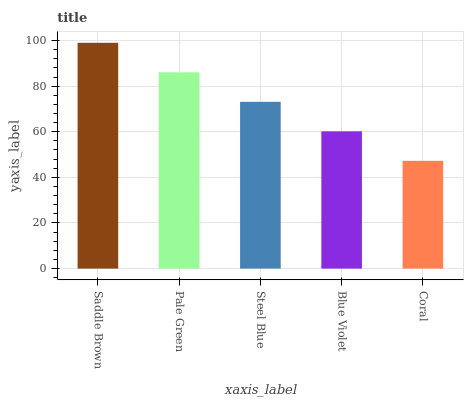Is Coral the minimum?
Answer yes or no. Yes. Is Saddle Brown the maximum?
Answer yes or no. Yes. Is Pale Green the minimum?
Answer yes or no. No. Is Pale Green the maximum?
Answer yes or no. No. Is Saddle Brown greater than Pale Green?
Answer yes or no. Yes. Is Pale Green less than Saddle Brown?
Answer yes or no. Yes. Is Pale Green greater than Saddle Brown?
Answer yes or no. No. Is Saddle Brown less than Pale Green?
Answer yes or no. No. Is Steel Blue the high median?
Answer yes or no. Yes. Is Steel Blue the low median?
Answer yes or no. Yes. Is Saddle Brown the high median?
Answer yes or no. No. Is Blue Violet the low median?
Answer yes or no. No. 